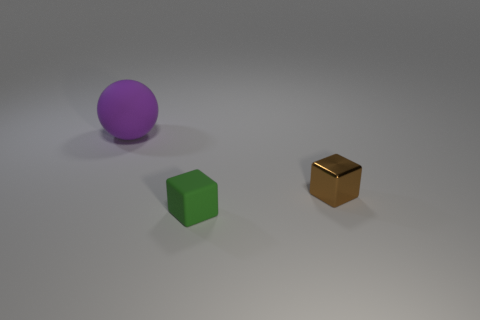Add 1 brown metal objects. How many objects exist? 4 Subtract 1 spheres. How many spheres are left? 0 Subtract all balls. How many objects are left? 2 Subtract all green cubes. How many cubes are left? 1 Add 1 small yellow metal blocks. How many small yellow metal blocks exist? 1 Subtract 1 purple spheres. How many objects are left? 2 Subtract all cyan balls. Subtract all red blocks. How many balls are left? 1 Subtract all tiny yellow metallic blocks. Subtract all purple rubber objects. How many objects are left? 2 Add 2 brown metal cubes. How many brown metal cubes are left? 3 